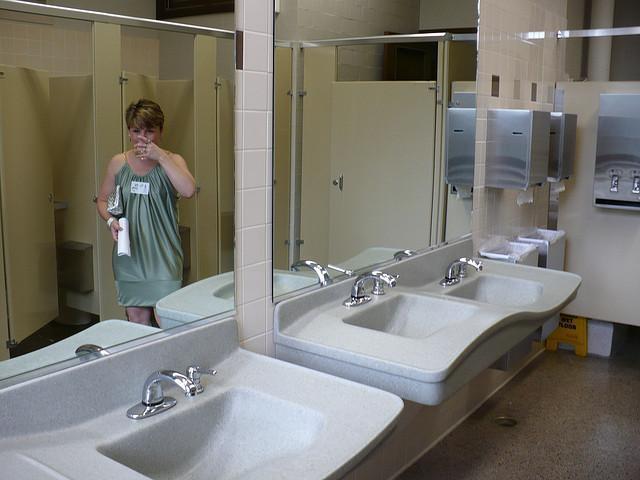How many sinks are visible?
Give a very brief answer. 3. How many mirrors are in the picture?
Give a very brief answer. 2. How many sinks are there?
Give a very brief answer. 4. 